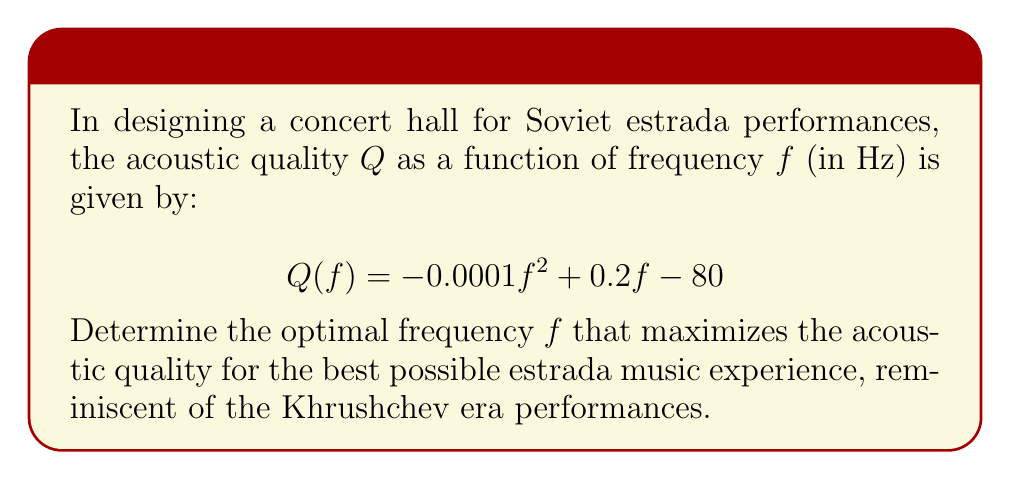Teach me how to tackle this problem. To find the optimal frequency that maximizes the acoustic quality, we need to find the maximum point of the quadratic function $Q(f)$. This can be done by finding the point where the derivative of $Q(f)$ equals zero.

Step 1: Find the derivative of $Q(f)$
$$Q'(f) = \frac{d}{df}(-0.0001f^2 + 0.2f - 80)$$
$$Q'(f) = -0.0002f + 0.2$$

Step 2: Set the derivative equal to zero and solve for $f$
$$-0.0002f + 0.2 = 0$$
$$-0.0002f = -0.2$$
$$f = \frac{-0.2}{-0.0002} = 1000$$

Step 3: Verify that this is a maximum point
The second derivative of $Q(f)$ is negative $(-0.0002)$, confirming that this point is a maximum.

Therefore, the optimal frequency for maximizing acoustic quality is 1000 Hz.
Answer: 1000 Hz 